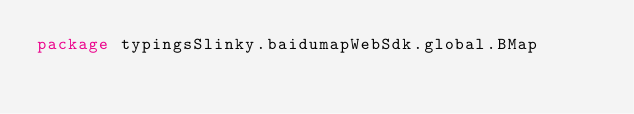Convert code to text. <code><loc_0><loc_0><loc_500><loc_500><_Scala_>package typingsSlinky.baidumapWebSdk.global.BMap
</code> 